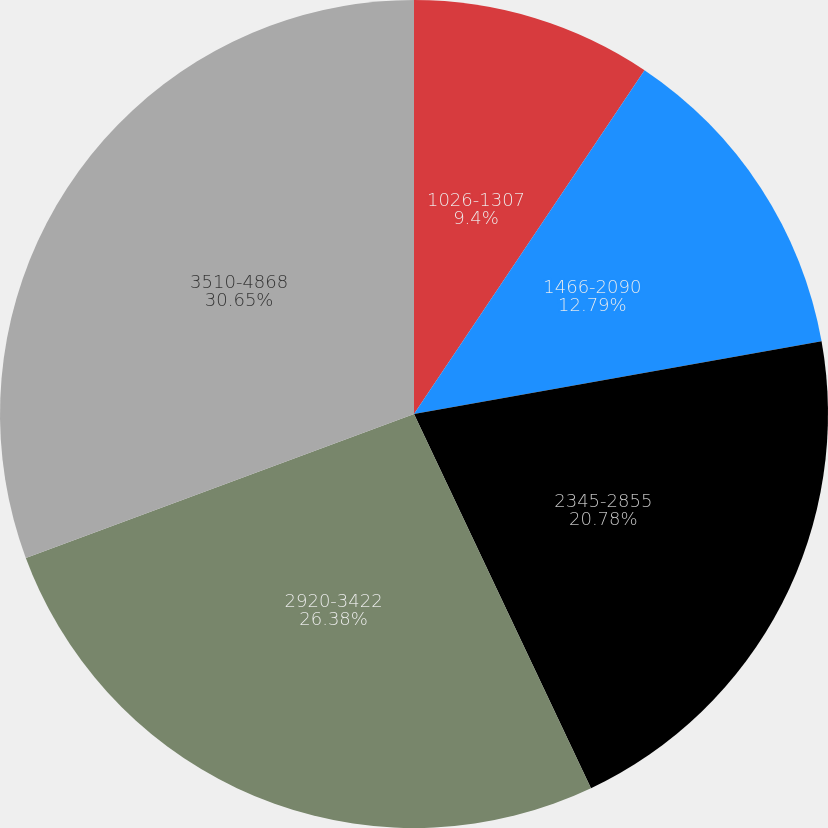<chart> <loc_0><loc_0><loc_500><loc_500><pie_chart><fcel>1026-1307<fcel>1466-2090<fcel>2345-2855<fcel>2920-3422<fcel>3510-4868<nl><fcel>9.4%<fcel>12.79%<fcel>20.78%<fcel>26.38%<fcel>30.65%<nl></chart> 